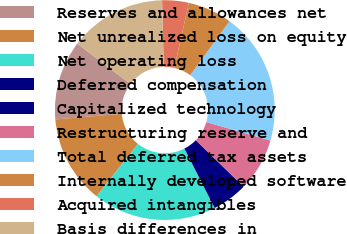<chart> <loc_0><loc_0><loc_500><loc_500><pie_chart><fcel>Reserves and allowances net<fcel>Net unrealized loss on equity<fcel>Net operating loss<fcel>Deferred compensation<fcel>Capitalized technology<fcel>Restructuring reserve and<fcel>Total deferred tax assets<fcel>Internally developed software<fcel>Acquired intangibles<fcel>Basis differences in<nl><fcel>11.68%<fcel>12.98%<fcel>18.16%<fcel>5.21%<fcel>0.03%<fcel>7.8%<fcel>19.45%<fcel>6.5%<fcel>3.91%<fcel>14.27%<nl></chart> 